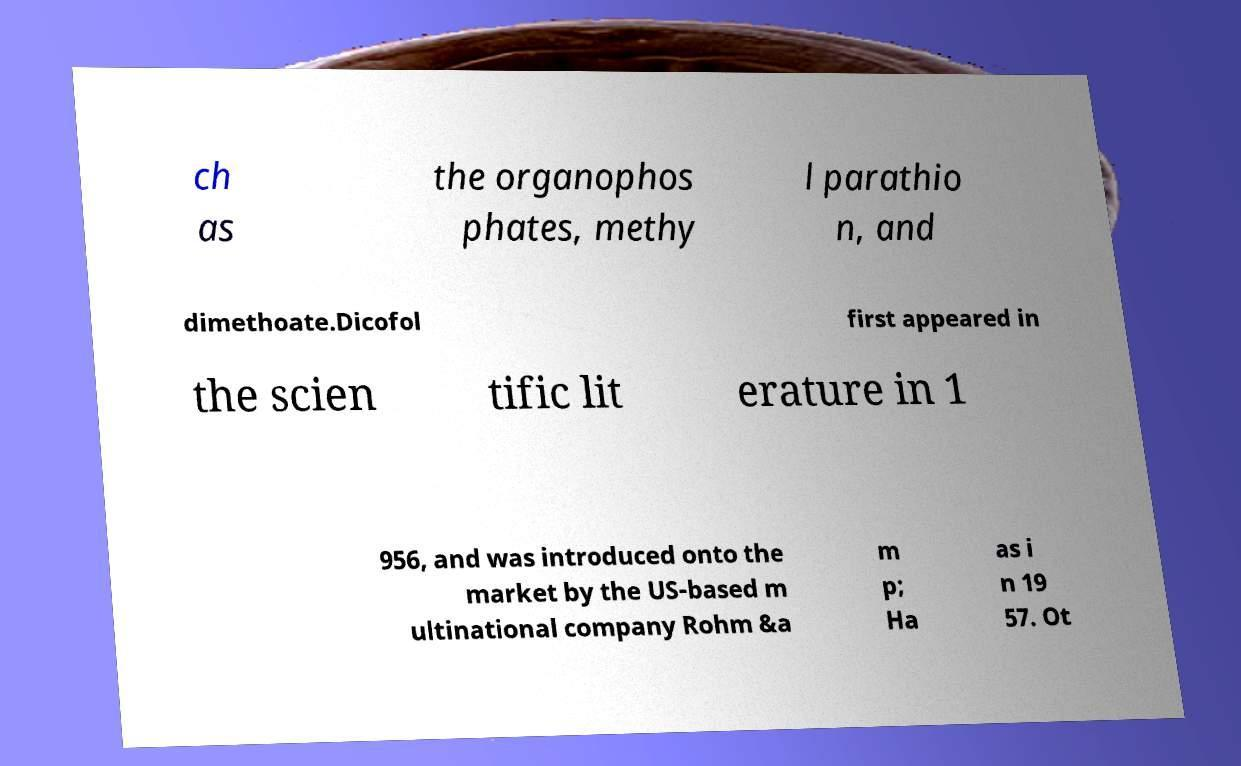For documentation purposes, I need the text within this image transcribed. Could you provide that? ch as the organophos phates, methy l parathio n, and dimethoate.Dicofol first appeared in the scien tific lit erature in 1 956, and was introduced onto the market by the US-based m ultinational company Rohm &a m p; Ha as i n 19 57. Ot 